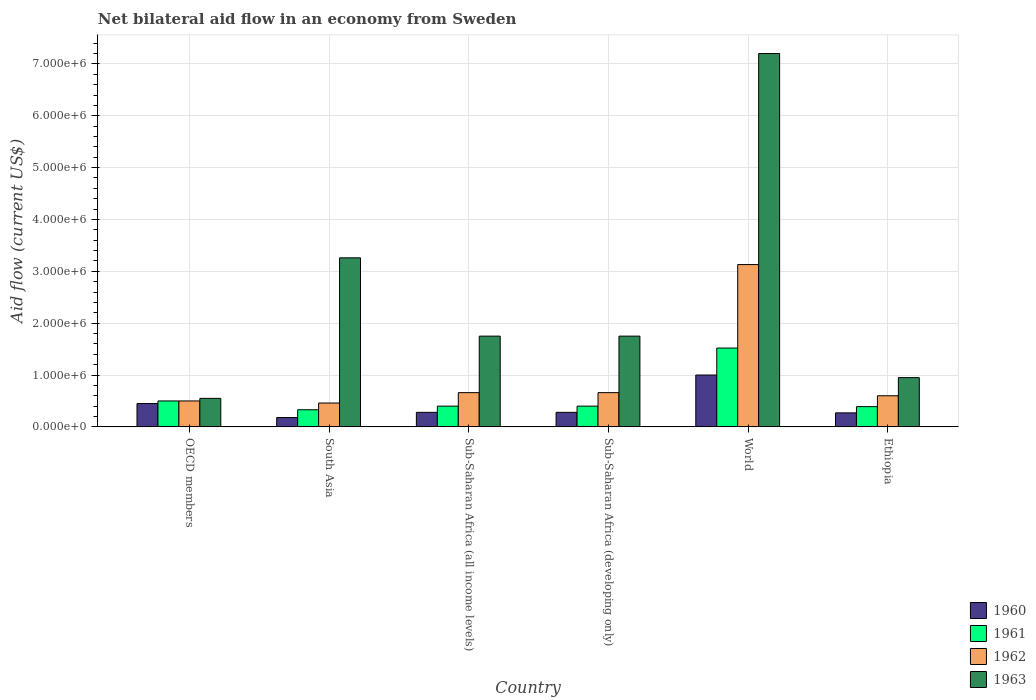How many groups of bars are there?
Offer a very short reply. 6. Are the number of bars per tick equal to the number of legend labels?
Provide a succinct answer. Yes. Are the number of bars on each tick of the X-axis equal?
Make the answer very short. Yes. What is the label of the 4th group of bars from the left?
Ensure brevity in your answer.  Sub-Saharan Africa (developing only). What is the net bilateral aid flow in 1960 in OECD members?
Provide a succinct answer. 4.50e+05. Across all countries, what is the maximum net bilateral aid flow in 1962?
Make the answer very short. 3.13e+06. Across all countries, what is the minimum net bilateral aid flow in 1960?
Offer a terse response. 1.80e+05. In which country was the net bilateral aid flow in 1963 maximum?
Your answer should be compact. World. What is the total net bilateral aid flow in 1961 in the graph?
Keep it short and to the point. 3.54e+06. What is the difference between the net bilateral aid flow in 1963 in Ethiopia and that in Sub-Saharan Africa (all income levels)?
Give a very brief answer. -8.00e+05. What is the difference between the net bilateral aid flow in 1961 in Ethiopia and the net bilateral aid flow in 1960 in World?
Offer a very short reply. -6.10e+05. What is the average net bilateral aid flow in 1962 per country?
Ensure brevity in your answer.  1.00e+06. What is the difference between the net bilateral aid flow of/in 1963 and net bilateral aid flow of/in 1961 in Ethiopia?
Your answer should be compact. 5.60e+05. What is the ratio of the net bilateral aid flow in 1962 in Sub-Saharan Africa (all income levels) to that in World?
Offer a very short reply. 0.21. Is the net bilateral aid flow in 1962 in Ethiopia less than that in Sub-Saharan Africa (all income levels)?
Your answer should be compact. Yes. Is the difference between the net bilateral aid flow in 1963 in Ethiopia and Sub-Saharan Africa (developing only) greater than the difference between the net bilateral aid flow in 1961 in Ethiopia and Sub-Saharan Africa (developing only)?
Keep it short and to the point. No. What is the difference between the highest and the second highest net bilateral aid flow in 1961?
Ensure brevity in your answer.  1.02e+06. What is the difference between the highest and the lowest net bilateral aid flow in 1963?
Give a very brief answer. 6.65e+06. What does the 2nd bar from the left in Sub-Saharan Africa (developing only) represents?
Ensure brevity in your answer.  1961. What does the 1st bar from the right in Sub-Saharan Africa (all income levels) represents?
Provide a short and direct response. 1963. Is it the case that in every country, the sum of the net bilateral aid flow in 1962 and net bilateral aid flow in 1961 is greater than the net bilateral aid flow in 1963?
Your response must be concise. No. How many bars are there?
Your answer should be compact. 24. Are all the bars in the graph horizontal?
Make the answer very short. No. What is the difference between two consecutive major ticks on the Y-axis?
Offer a very short reply. 1.00e+06. Does the graph contain any zero values?
Keep it short and to the point. No. How many legend labels are there?
Give a very brief answer. 4. How are the legend labels stacked?
Provide a short and direct response. Vertical. What is the title of the graph?
Your answer should be very brief. Net bilateral aid flow in an economy from Sweden. What is the label or title of the X-axis?
Give a very brief answer. Country. What is the Aid flow (current US$) of 1961 in OECD members?
Offer a terse response. 5.00e+05. What is the Aid flow (current US$) of 1962 in OECD members?
Your answer should be compact. 5.00e+05. What is the Aid flow (current US$) of 1963 in OECD members?
Ensure brevity in your answer.  5.50e+05. What is the Aid flow (current US$) in 1961 in South Asia?
Your answer should be very brief. 3.30e+05. What is the Aid flow (current US$) of 1962 in South Asia?
Offer a very short reply. 4.60e+05. What is the Aid flow (current US$) in 1963 in South Asia?
Your response must be concise. 3.26e+06. What is the Aid flow (current US$) of 1961 in Sub-Saharan Africa (all income levels)?
Your answer should be compact. 4.00e+05. What is the Aid flow (current US$) in 1962 in Sub-Saharan Africa (all income levels)?
Offer a terse response. 6.60e+05. What is the Aid flow (current US$) of 1963 in Sub-Saharan Africa (all income levels)?
Make the answer very short. 1.75e+06. What is the Aid flow (current US$) of 1961 in Sub-Saharan Africa (developing only)?
Provide a succinct answer. 4.00e+05. What is the Aid flow (current US$) in 1963 in Sub-Saharan Africa (developing only)?
Make the answer very short. 1.75e+06. What is the Aid flow (current US$) in 1961 in World?
Your response must be concise. 1.52e+06. What is the Aid flow (current US$) in 1962 in World?
Make the answer very short. 3.13e+06. What is the Aid flow (current US$) of 1963 in World?
Offer a terse response. 7.20e+06. What is the Aid flow (current US$) in 1960 in Ethiopia?
Keep it short and to the point. 2.70e+05. What is the Aid flow (current US$) in 1961 in Ethiopia?
Make the answer very short. 3.90e+05. What is the Aid flow (current US$) in 1963 in Ethiopia?
Ensure brevity in your answer.  9.50e+05. Across all countries, what is the maximum Aid flow (current US$) of 1960?
Your answer should be very brief. 1.00e+06. Across all countries, what is the maximum Aid flow (current US$) in 1961?
Your answer should be compact. 1.52e+06. Across all countries, what is the maximum Aid flow (current US$) of 1962?
Keep it short and to the point. 3.13e+06. Across all countries, what is the maximum Aid flow (current US$) in 1963?
Your response must be concise. 7.20e+06. Across all countries, what is the minimum Aid flow (current US$) of 1960?
Keep it short and to the point. 1.80e+05. Across all countries, what is the minimum Aid flow (current US$) in 1961?
Ensure brevity in your answer.  3.30e+05. Across all countries, what is the minimum Aid flow (current US$) in 1962?
Offer a very short reply. 4.60e+05. Across all countries, what is the minimum Aid flow (current US$) in 1963?
Your response must be concise. 5.50e+05. What is the total Aid flow (current US$) in 1960 in the graph?
Keep it short and to the point. 2.46e+06. What is the total Aid flow (current US$) in 1961 in the graph?
Give a very brief answer. 3.54e+06. What is the total Aid flow (current US$) of 1962 in the graph?
Provide a short and direct response. 6.01e+06. What is the total Aid flow (current US$) of 1963 in the graph?
Offer a terse response. 1.55e+07. What is the difference between the Aid flow (current US$) of 1962 in OECD members and that in South Asia?
Provide a succinct answer. 4.00e+04. What is the difference between the Aid flow (current US$) of 1963 in OECD members and that in South Asia?
Ensure brevity in your answer.  -2.71e+06. What is the difference between the Aid flow (current US$) of 1963 in OECD members and that in Sub-Saharan Africa (all income levels)?
Offer a terse response. -1.20e+06. What is the difference between the Aid flow (current US$) in 1960 in OECD members and that in Sub-Saharan Africa (developing only)?
Your answer should be very brief. 1.70e+05. What is the difference between the Aid flow (current US$) of 1963 in OECD members and that in Sub-Saharan Africa (developing only)?
Offer a very short reply. -1.20e+06. What is the difference between the Aid flow (current US$) in 1960 in OECD members and that in World?
Offer a terse response. -5.50e+05. What is the difference between the Aid flow (current US$) in 1961 in OECD members and that in World?
Offer a very short reply. -1.02e+06. What is the difference between the Aid flow (current US$) of 1962 in OECD members and that in World?
Offer a terse response. -2.63e+06. What is the difference between the Aid flow (current US$) of 1963 in OECD members and that in World?
Give a very brief answer. -6.65e+06. What is the difference between the Aid flow (current US$) of 1960 in OECD members and that in Ethiopia?
Ensure brevity in your answer.  1.80e+05. What is the difference between the Aid flow (current US$) of 1961 in OECD members and that in Ethiopia?
Provide a short and direct response. 1.10e+05. What is the difference between the Aid flow (current US$) in 1962 in OECD members and that in Ethiopia?
Give a very brief answer. -1.00e+05. What is the difference between the Aid flow (current US$) in 1963 in OECD members and that in Ethiopia?
Your response must be concise. -4.00e+05. What is the difference between the Aid flow (current US$) of 1960 in South Asia and that in Sub-Saharan Africa (all income levels)?
Give a very brief answer. -1.00e+05. What is the difference between the Aid flow (current US$) in 1961 in South Asia and that in Sub-Saharan Africa (all income levels)?
Offer a terse response. -7.00e+04. What is the difference between the Aid flow (current US$) in 1963 in South Asia and that in Sub-Saharan Africa (all income levels)?
Your answer should be compact. 1.51e+06. What is the difference between the Aid flow (current US$) of 1960 in South Asia and that in Sub-Saharan Africa (developing only)?
Give a very brief answer. -1.00e+05. What is the difference between the Aid flow (current US$) of 1961 in South Asia and that in Sub-Saharan Africa (developing only)?
Ensure brevity in your answer.  -7.00e+04. What is the difference between the Aid flow (current US$) in 1963 in South Asia and that in Sub-Saharan Africa (developing only)?
Ensure brevity in your answer.  1.51e+06. What is the difference between the Aid flow (current US$) of 1960 in South Asia and that in World?
Provide a succinct answer. -8.20e+05. What is the difference between the Aid flow (current US$) in 1961 in South Asia and that in World?
Make the answer very short. -1.19e+06. What is the difference between the Aid flow (current US$) of 1962 in South Asia and that in World?
Offer a very short reply. -2.67e+06. What is the difference between the Aid flow (current US$) of 1963 in South Asia and that in World?
Ensure brevity in your answer.  -3.94e+06. What is the difference between the Aid flow (current US$) of 1960 in South Asia and that in Ethiopia?
Your answer should be very brief. -9.00e+04. What is the difference between the Aid flow (current US$) in 1963 in South Asia and that in Ethiopia?
Provide a succinct answer. 2.31e+06. What is the difference between the Aid flow (current US$) in 1960 in Sub-Saharan Africa (all income levels) and that in Sub-Saharan Africa (developing only)?
Offer a terse response. 0. What is the difference between the Aid flow (current US$) in 1962 in Sub-Saharan Africa (all income levels) and that in Sub-Saharan Africa (developing only)?
Give a very brief answer. 0. What is the difference between the Aid flow (current US$) in 1960 in Sub-Saharan Africa (all income levels) and that in World?
Offer a very short reply. -7.20e+05. What is the difference between the Aid flow (current US$) in 1961 in Sub-Saharan Africa (all income levels) and that in World?
Provide a short and direct response. -1.12e+06. What is the difference between the Aid flow (current US$) of 1962 in Sub-Saharan Africa (all income levels) and that in World?
Provide a short and direct response. -2.47e+06. What is the difference between the Aid flow (current US$) in 1963 in Sub-Saharan Africa (all income levels) and that in World?
Ensure brevity in your answer.  -5.45e+06. What is the difference between the Aid flow (current US$) in 1962 in Sub-Saharan Africa (all income levels) and that in Ethiopia?
Your answer should be very brief. 6.00e+04. What is the difference between the Aid flow (current US$) in 1963 in Sub-Saharan Africa (all income levels) and that in Ethiopia?
Your answer should be very brief. 8.00e+05. What is the difference between the Aid flow (current US$) in 1960 in Sub-Saharan Africa (developing only) and that in World?
Offer a terse response. -7.20e+05. What is the difference between the Aid flow (current US$) in 1961 in Sub-Saharan Africa (developing only) and that in World?
Ensure brevity in your answer.  -1.12e+06. What is the difference between the Aid flow (current US$) of 1962 in Sub-Saharan Africa (developing only) and that in World?
Offer a very short reply. -2.47e+06. What is the difference between the Aid flow (current US$) in 1963 in Sub-Saharan Africa (developing only) and that in World?
Keep it short and to the point. -5.45e+06. What is the difference between the Aid flow (current US$) of 1962 in Sub-Saharan Africa (developing only) and that in Ethiopia?
Offer a terse response. 6.00e+04. What is the difference between the Aid flow (current US$) in 1963 in Sub-Saharan Africa (developing only) and that in Ethiopia?
Offer a very short reply. 8.00e+05. What is the difference between the Aid flow (current US$) in 1960 in World and that in Ethiopia?
Keep it short and to the point. 7.30e+05. What is the difference between the Aid flow (current US$) in 1961 in World and that in Ethiopia?
Your answer should be very brief. 1.13e+06. What is the difference between the Aid flow (current US$) in 1962 in World and that in Ethiopia?
Provide a short and direct response. 2.53e+06. What is the difference between the Aid flow (current US$) of 1963 in World and that in Ethiopia?
Ensure brevity in your answer.  6.25e+06. What is the difference between the Aid flow (current US$) in 1960 in OECD members and the Aid flow (current US$) in 1961 in South Asia?
Offer a terse response. 1.20e+05. What is the difference between the Aid flow (current US$) of 1960 in OECD members and the Aid flow (current US$) of 1962 in South Asia?
Provide a succinct answer. -10000. What is the difference between the Aid flow (current US$) of 1960 in OECD members and the Aid flow (current US$) of 1963 in South Asia?
Offer a terse response. -2.81e+06. What is the difference between the Aid flow (current US$) in 1961 in OECD members and the Aid flow (current US$) in 1963 in South Asia?
Give a very brief answer. -2.76e+06. What is the difference between the Aid flow (current US$) of 1962 in OECD members and the Aid flow (current US$) of 1963 in South Asia?
Provide a succinct answer. -2.76e+06. What is the difference between the Aid flow (current US$) of 1960 in OECD members and the Aid flow (current US$) of 1961 in Sub-Saharan Africa (all income levels)?
Offer a terse response. 5.00e+04. What is the difference between the Aid flow (current US$) of 1960 in OECD members and the Aid flow (current US$) of 1962 in Sub-Saharan Africa (all income levels)?
Give a very brief answer. -2.10e+05. What is the difference between the Aid flow (current US$) of 1960 in OECD members and the Aid flow (current US$) of 1963 in Sub-Saharan Africa (all income levels)?
Offer a very short reply. -1.30e+06. What is the difference between the Aid flow (current US$) in 1961 in OECD members and the Aid flow (current US$) in 1962 in Sub-Saharan Africa (all income levels)?
Your answer should be very brief. -1.60e+05. What is the difference between the Aid flow (current US$) in 1961 in OECD members and the Aid flow (current US$) in 1963 in Sub-Saharan Africa (all income levels)?
Give a very brief answer. -1.25e+06. What is the difference between the Aid flow (current US$) in 1962 in OECD members and the Aid flow (current US$) in 1963 in Sub-Saharan Africa (all income levels)?
Make the answer very short. -1.25e+06. What is the difference between the Aid flow (current US$) in 1960 in OECD members and the Aid flow (current US$) in 1961 in Sub-Saharan Africa (developing only)?
Ensure brevity in your answer.  5.00e+04. What is the difference between the Aid flow (current US$) in 1960 in OECD members and the Aid flow (current US$) in 1962 in Sub-Saharan Africa (developing only)?
Keep it short and to the point. -2.10e+05. What is the difference between the Aid flow (current US$) in 1960 in OECD members and the Aid flow (current US$) in 1963 in Sub-Saharan Africa (developing only)?
Your answer should be very brief. -1.30e+06. What is the difference between the Aid flow (current US$) in 1961 in OECD members and the Aid flow (current US$) in 1963 in Sub-Saharan Africa (developing only)?
Offer a very short reply. -1.25e+06. What is the difference between the Aid flow (current US$) of 1962 in OECD members and the Aid flow (current US$) of 1963 in Sub-Saharan Africa (developing only)?
Ensure brevity in your answer.  -1.25e+06. What is the difference between the Aid flow (current US$) in 1960 in OECD members and the Aid flow (current US$) in 1961 in World?
Your response must be concise. -1.07e+06. What is the difference between the Aid flow (current US$) in 1960 in OECD members and the Aid flow (current US$) in 1962 in World?
Make the answer very short. -2.68e+06. What is the difference between the Aid flow (current US$) in 1960 in OECD members and the Aid flow (current US$) in 1963 in World?
Ensure brevity in your answer.  -6.75e+06. What is the difference between the Aid flow (current US$) in 1961 in OECD members and the Aid flow (current US$) in 1962 in World?
Offer a terse response. -2.63e+06. What is the difference between the Aid flow (current US$) of 1961 in OECD members and the Aid flow (current US$) of 1963 in World?
Keep it short and to the point. -6.70e+06. What is the difference between the Aid flow (current US$) in 1962 in OECD members and the Aid flow (current US$) in 1963 in World?
Your answer should be very brief. -6.70e+06. What is the difference between the Aid flow (current US$) in 1960 in OECD members and the Aid flow (current US$) in 1961 in Ethiopia?
Your answer should be very brief. 6.00e+04. What is the difference between the Aid flow (current US$) of 1960 in OECD members and the Aid flow (current US$) of 1962 in Ethiopia?
Offer a very short reply. -1.50e+05. What is the difference between the Aid flow (current US$) of 1960 in OECD members and the Aid flow (current US$) of 1963 in Ethiopia?
Ensure brevity in your answer.  -5.00e+05. What is the difference between the Aid flow (current US$) of 1961 in OECD members and the Aid flow (current US$) of 1962 in Ethiopia?
Provide a succinct answer. -1.00e+05. What is the difference between the Aid flow (current US$) in 1961 in OECD members and the Aid flow (current US$) in 1963 in Ethiopia?
Provide a succinct answer. -4.50e+05. What is the difference between the Aid flow (current US$) in 1962 in OECD members and the Aid flow (current US$) in 1963 in Ethiopia?
Make the answer very short. -4.50e+05. What is the difference between the Aid flow (current US$) in 1960 in South Asia and the Aid flow (current US$) in 1962 in Sub-Saharan Africa (all income levels)?
Make the answer very short. -4.80e+05. What is the difference between the Aid flow (current US$) of 1960 in South Asia and the Aid flow (current US$) of 1963 in Sub-Saharan Africa (all income levels)?
Your answer should be compact. -1.57e+06. What is the difference between the Aid flow (current US$) of 1961 in South Asia and the Aid flow (current US$) of 1962 in Sub-Saharan Africa (all income levels)?
Make the answer very short. -3.30e+05. What is the difference between the Aid flow (current US$) in 1961 in South Asia and the Aid flow (current US$) in 1963 in Sub-Saharan Africa (all income levels)?
Your response must be concise. -1.42e+06. What is the difference between the Aid flow (current US$) in 1962 in South Asia and the Aid flow (current US$) in 1963 in Sub-Saharan Africa (all income levels)?
Give a very brief answer. -1.29e+06. What is the difference between the Aid flow (current US$) of 1960 in South Asia and the Aid flow (current US$) of 1962 in Sub-Saharan Africa (developing only)?
Ensure brevity in your answer.  -4.80e+05. What is the difference between the Aid flow (current US$) in 1960 in South Asia and the Aid flow (current US$) in 1963 in Sub-Saharan Africa (developing only)?
Make the answer very short. -1.57e+06. What is the difference between the Aid flow (current US$) in 1961 in South Asia and the Aid flow (current US$) in 1962 in Sub-Saharan Africa (developing only)?
Your answer should be compact. -3.30e+05. What is the difference between the Aid flow (current US$) of 1961 in South Asia and the Aid flow (current US$) of 1963 in Sub-Saharan Africa (developing only)?
Provide a short and direct response. -1.42e+06. What is the difference between the Aid flow (current US$) in 1962 in South Asia and the Aid flow (current US$) in 1963 in Sub-Saharan Africa (developing only)?
Keep it short and to the point. -1.29e+06. What is the difference between the Aid flow (current US$) of 1960 in South Asia and the Aid flow (current US$) of 1961 in World?
Your response must be concise. -1.34e+06. What is the difference between the Aid flow (current US$) of 1960 in South Asia and the Aid flow (current US$) of 1962 in World?
Provide a succinct answer. -2.95e+06. What is the difference between the Aid flow (current US$) in 1960 in South Asia and the Aid flow (current US$) in 1963 in World?
Ensure brevity in your answer.  -7.02e+06. What is the difference between the Aid flow (current US$) in 1961 in South Asia and the Aid flow (current US$) in 1962 in World?
Give a very brief answer. -2.80e+06. What is the difference between the Aid flow (current US$) of 1961 in South Asia and the Aid flow (current US$) of 1963 in World?
Your answer should be very brief. -6.87e+06. What is the difference between the Aid flow (current US$) of 1962 in South Asia and the Aid flow (current US$) of 1963 in World?
Your answer should be compact. -6.74e+06. What is the difference between the Aid flow (current US$) in 1960 in South Asia and the Aid flow (current US$) in 1962 in Ethiopia?
Ensure brevity in your answer.  -4.20e+05. What is the difference between the Aid flow (current US$) of 1960 in South Asia and the Aid flow (current US$) of 1963 in Ethiopia?
Offer a terse response. -7.70e+05. What is the difference between the Aid flow (current US$) of 1961 in South Asia and the Aid flow (current US$) of 1962 in Ethiopia?
Ensure brevity in your answer.  -2.70e+05. What is the difference between the Aid flow (current US$) in 1961 in South Asia and the Aid flow (current US$) in 1963 in Ethiopia?
Make the answer very short. -6.20e+05. What is the difference between the Aid flow (current US$) in 1962 in South Asia and the Aid flow (current US$) in 1963 in Ethiopia?
Your response must be concise. -4.90e+05. What is the difference between the Aid flow (current US$) in 1960 in Sub-Saharan Africa (all income levels) and the Aid flow (current US$) in 1962 in Sub-Saharan Africa (developing only)?
Offer a very short reply. -3.80e+05. What is the difference between the Aid flow (current US$) of 1960 in Sub-Saharan Africa (all income levels) and the Aid flow (current US$) of 1963 in Sub-Saharan Africa (developing only)?
Offer a very short reply. -1.47e+06. What is the difference between the Aid flow (current US$) of 1961 in Sub-Saharan Africa (all income levels) and the Aid flow (current US$) of 1963 in Sub-Saharan Africa (developing only)?
Your response must be concise. -1.35e+06. What is the difference between the Aid flow (current US$) in 1962 in Sub-Saharan Africa (all income levels) and the Aid flow (current US$) in 1963 in Sub-Saharan Africa (developing only)?
Ensure brevity in your answer.  -1.09e+06. What is the difference between the Aid flow (current US$) of 1960 in Sub-Saharan Africa (all income levels) and the Aid flow (current US$) of 1961 in World?
Provide a succinct answer. -1.24e+06. What is the difference between the Aid flow (current US$) of 1960 in Sub-Saharan Africa (all income levels) and the Aid flow (current US$) of 1962 in World?
Your answer should be very brief. -2.85e+06. What is the difference between the Aid flow (current US$) of 1960 in Sub-Saharan Africa (all income levels) and the Aid flow (current US$) of 1963 in World?
Your response must be concise. -6.92e+06. What is the difference between the Aid flow (current US$) in 1961 in Sub-Saharan Africa (all income levels) and the Aid flow (current US$) in 1962 in World?
Your answer should be compact. -2.73e+06. What is the difference between the Aid flow (current US$) in 1961 in Sub-Saharan Africa (all income levels) and the Aid flow (current US$) in 1963 in World?
Ensure brevity in your answer.  -6.80e+06. What is the difference between the Aid flow (current US$) in 1962 in Sub-Saharan Africa (all income levels) and the Aid flow (current US$) in 1963 in World?
Offer a very short reply. -6.54e+06. What is the difference between the Aid flow (current US$) in 1960 in Sub-Saharan Africa (all income levels) and the Aid flow (current US$) in 1961 in Ethiopia?
Provide a succinct answer. -1.10e+05. What is the difference between the Aid flow (current US$) of 1960 in Sub-Saharan Africa (all income levels) and the Aid flow (current US$) of 1962 in Ethiopia?
Give a very brief answer. -3.20e+05. What is the difference between the Aid flow (current US$) in 1960 in Sub-Saharan Africa (all income levels) and the Aid flow (current US$) in 1963 in Ethiopia?
Give a very brief answer. -6.70e+05. What is the difference between the Aid flow (current US$) in 1961 in Sub-Saharan Africa (all income levels) and the Aid flow (current US$) in 1962 in Ethiopia?
Your answer should be compact. -2.00e+05. What is the difference between the Aid flow (current US$) of 1961 in Sub-Saharan Africa (all income levels) and the Aid flow (current US$) of 1963 in Ethiopia?
Provide a short and direct response. -5.50e+05. What is the difference between the Aid flow (current US$) in 1960 in Sub-Saharan Africa (developing only) and the Aid flow (current US$) in 1961 in World?
Offer a terse response. -1.24e+06. What is the difference between the Aid flow (current US$) of 1960 in Sub-Saharan Africa (developing only) and the Aid flow (current US$) of 1962 in World?
Provide a short and direct response. -2.85e+06. What is the difference between the Aid flow (current US$) of 1960 in Sub-Saharan Africa (developing only) and the Aid flow (current US$) of 1963 in World?
Offer a terse response. -6.92e+06. What is the difference between the Aid flow (current US$) in 1961 in Sub-Saharan Africa (developing only) and the Aid flow (current US$) in 1962 in World?
Give a very brief answer. -2.73e+06. What is the difference between the Aid flow (current US$) in 1961 in Sub-Saharan Africa (developing only) and the Aid flow (current US$) in 1963 in World?
Offer a very short reply. -6.80e+06. What is the difference between the Aid flow (current US$) in 1962 in Sub-Saharan Africa (developing only) and the Aid flow (current US$) in 1963 in World?
Make the answer very short. -6.54e+06. What is the difference between the Aid flow (current US$) of 1960 in Sub-Saharan Africa (developing only) and the Aid flow (current US$) of 1962 in Ethiopia?
Your answer should be compact. -3.20e+05. What is the difference between the Aid flow (current US$) of 1960 in Sub-Saharan Africa (developing only) and the Aid flow (current US$) of 1963 in Ethiopia?
Offer a terse response. -6.70e+05. What is the difference between the Aid flow (current US$) of 1961 in Sub-Saharan Africa (developing only) and the Aid flow (current US$) of 1963 in Ethiopia?
Give a very brief answer. -5.50e+05. What is the difference between the Aid flow (current US$) of 1962 in Sub-Saharan Africa (developing only) and the Aid flow (current US$) of 1963 in Ethiopia?
Ensure brevity in your answer.  -2.90e+05. What is the difference between the Aid flow (current US$) in 1960 in World and the Aid flow (current US$) in 1962 in Ethiopia?
Offer a terse response. 4.00e+05. What is the difference between the Aid flow (current US$) in 1961 in World and the Aid flow (current US$) in 1962 in Ethiopia?
Make the answer very short. 9.20e+05. What is the difference between the Aid flow (current US$) of 1961 in World and the Aid flow (current US$) of 1963 in Ethiopia?
Offer a very short reply. 5.70e+05. What is the difference between the Aid flow (current US$) of 1962 in World and the Aid flow (current US$) of 1963 in Ethiopia?
Provide a succinct answer. 2.18e+06. What is the average Aid flow (current US$) of 1960 per country?
Your answer should be compact. 4.10e+05. What is the average Aid flow (current US$) in 1961 per country?
Offer a very short reply. 5.90e+05. What is the average Aid flow (current US$) of 1962 per country?
Make the answer very short. 1.00e+06. What is the average Aid flow (current US$) in 1963 per country?
Your answer should be very brief. 2.58e+06. What is the difference between the Aid flow (current US$) in 1960 and Aid flow (current US$) in 1961 in OECD members?
Your response must be concise. -5.00e+04. What is the difference between the Aid flow (current US$) in 1960 and Aid flow (current US$) in 1963 in OECD members?
Your answer should be very brief. -1.00e+05. What is the difference between the Aid flow (current US$) in 1960 and Aid flow (current US$) in 1962 in South Asia?
Make the answer very short. -2.80e+05. What is the difference between the Aid flow (current US$) in 1960 and Aid flow (current US$) in 1963 in South Asia?
Provide a succinct answer. -3.08e+06. What is the difference between the Aid flow (current US$) in 1961 and Aid flow (current US$) in 1963 in South Asia?
Offer a terse response. -2.93e+06. What is the difference between the Aid flow (current US$) of 1962 and Aid flow (current US$) of 1963 in South Asia?
Provide a short and direct response. -2.80e+06. What is the difference between the Aid flow (current US$) in 1960 and Aid flow (current US$) in 1961 in Sub-Saharan Africa (all income levels)?
Make the answer very short. -1.20e+05. What is the difference between the Aid flow (current US$) in 1960 and Aid flow (current US$) in 1962 in Sub-Saharan Africa (all income levels)?
Your answer should be compact. -3.80e+05. What is the difference between the Aid flow (current US$) in 1960 and Aid flow (current US$) in 1963 in Sub-Saharan Africa (all income levels)?
Provide a succinct answer. -1.47e+06. What is the difference between the Aid flow (current US$) in 1961 and Aid flow (current US$) in 1963 in Sub-Saharan Africa (all income levels)?
Your answer should be very brief. -1.35e+06. What is the difference between the Aid flow (current US$) in 1962 and Aid flow (current US$) in 1963 in Sub-Saharan Africa (all income levels)?
Provide a short and direct response. -1.09e+06. What is the difference between the Aid flow (current US$) in 1960 and Aid flow (current US$) in 1961 in Sub-Saharan Africa (developing only)?
Make the answer very short. -1.20e+05. What is the difference between the Aid flow (current US$) in 1960 and Aid flow (current US$) in 1962 in Sub-Saharan Africa (developing only)?
Offer a terse response. -3.80e+05. What is the difference between the Aid flow (current US$) in 1960 and Aid flow (current US$) in 1963 in Sub-Saharan Africa (developing only)?
Offer a very short reply. -1.47e+06. What is the difference between the Aid flow (current US$) of 1961 and Aid flow (current US$) of 1962 in Sub-Saharan Africa (developing only)?
Provide a short and direct response. -2.60e+05. What is the difference between the Aid flow (current US$) of 1961 and Aid flow (current US$) of 1963 in Sub-Saharan Africa (developing only)?
Keep it short and to the point. -1.35e+06. What is the difference between the Aid flow (current US$) of 1962 and Aid flow (current US$) of 1963 in Sub-Saharan Africa (developing only)?
Ensure brevity in your answer.  -1.09e+06. What is the difference between the Aid flow (current US$) of 1960 and Aid flow (current US$) of 1961 in World?
Ensure brevity in your answer.  -5.20e+05. What is the difference between the Aid flow (current US$) of 1960 and Aid flow (current US$) of 1962 in World?
Offer a terse response. -2.13e+06. What is the difference between the Aid flow (current US$) of 1960 and Aid flow (current US$) of 1963 in World?
Your answer should be compact. -6.20e+06. What is the difference between the Aid flow (current US$) in 1961 and Aid flow (current US$) in 1962 in World?
Ensure brevity in your answer.  -1.61e+06. What is the difference between the Aid flow (current US$) of 1961 and Aid flow (current US$) of 1963 in World?
Keep it short and to the point. -5.68e+06. What is the difference between the Aid flow (current US$) of 1962 and Aid flow (current US$) of 1963 in World?
Your answer should be very brief. -4.07e+06. What is the difference between the Aid flow (current US$) of 1960 and Aid flow (current US$) of 1961 in Ethiopia?
Keep it short and to the point. -1.20e+05. What is the difference between the Aid flow (current US$) of 1960 and Aid flow (current US$) of 1962 in Ethiopia?
Provide a short and direct response. -3.30e+05. What is the difference between the Aid flow (current US$) in 1960 and Aid flow (current US$) in 1963 in Ethiopia?
Your answer should be very brief. -6.80e+05. What is the difference between the Aid flow (current US$) in 1961 and Aid flow (current US$) in 1962 in Ethiopia?
Your response must be concise. -2.10e+05. What is the difference between the Aid flow (current US$) of 1961 and Aid flow (current US$) of 1963 in Ethiopia?
Your answer should be very brief. -5.60e+05. What is the difference between the Aid flow (current US$) of 1962 and Aid flow (current US$) of 1963 in Ethiopia?
Your response must be concise. -3.50e+05. What is the ratio of the Aid flow (current US$) of 1960 in OECD members to that in South Asia?
Your answer should be very brief. 2.5. What is the ratio of the Aid flow (current US$) in 1961 in OECD members to that in South Asia?
Make the answer very short. 1.52. What is the ratio of the Aid flow (current US$) in 1962 in OECD members to that in South Asia?
Make the answer very short. 1.09. What is the ratio of the Aid flow (current US$) in 1963 in OECD members to that in South Asia?
Offer a terse response. 0.17. What is the ratio of the Aid flow (current US$) of 1960 in OECD members to that in Sub-Saharan Africa (all income levels)?
Provide a short and direct response. 1.61. What is the ratio of the Aid flow (current US$) of 1961 in OECD members to that in Sub-Saharan Africa (all income levels)?
Provide a short and direct response. 1.25. What is the ratio of the Aid flow (current US$) of 1962 in OECD members to that in Sub-Saharan Africa (all income levels)?
Offer a terse response. 0.76. What is the ratio of the Aid flow (current US$) in 1963 in OECD members to that in Sub-Saharan Africa (all income levels)?
Give a very brief answer. 0.31. What is the ratio of the Aid flow (current US$) of 1960 in OECD members to that in Sub-Saharan Africa (developing only)?
Ensure brevity in your answer.  1.61. What is the ratio of the Aid flow (current US$) of 1961 in OECD members to that in Sub-Saharan Africa (developing only)?
Make the answer very short. 1.25. What is the ratio of the Aid flow (current US$) of 1962 in OECD members to that in Sub-Saharan Africa (developing only)?
Make the answer very short. 0.76. What is the ratio of the Aid flow (current US$) in 1963 in OECD members to that in Sub-Saharan Africa (developing only)?
Your response must be concise. 0.31. What is the ratio of the Aid flow (current US$) of 1960 in OECD members to that in World?
Offer a very short reply. 0.45. What is the ratio of the Aid flow (current US$) in 1961 in OECD members to that in World?
Your answer should be very brief. 0.33. What is the ratio of the Aid flow (current US$) of 1962 in OECD members to that in World?
Give a very brief answer. 0.16. What is the ratio of the Aid flow (current US$) in 1963 in OECD members to that in World?
Provide a succinct answer. 0.08. What is the ratio of the Aid flow (current US$) of 1961 in OECD members to that in Ethiopia?
Provide a succinct answer. 1.28. What is the ratio of the Aid flow (current US$) of 1963 in OECD members to that in Ethiopia?
Provide a succinct answer. 0.58. What is the ratio of the Aid flow (current US$) of 1960 in South Asia to that in Sub-Saharan Africa (all income levels)?
Your answer should be compact. 0.64. What is the ratio of the Aid flow (current US$) in 1961 in South Asia to that in Sub-Saharan Africa (all income levels)?
Your answer should be compact. 0.82. What is the ratio of the Aid flow (current US$) of 1962 in South Asia to that in Sub-Saharan Africa (all income levels)?
Provide a short and direct response. 0.7. What is the ratio of the Aid flow (current US$) in 1963 in South Asia to that in Sub-Saharan Africa (all income levels)?
Offer a terse response. 1.86. What is the ratio of the Aid flow (current US$) in 1960 in South Asia to that in Sub-Saharan Africa (developing only)?
Give a very brief answer. 0.64. What is the ratio of the Aid flow (current US$) in 1961 in South Asia to that in Sub-Saharan Africa (developing only)?
Provide a succinct answer. 0.82. What is the ratio of the Aid flow (current US$) of 1962 in South Asia to that in Sub-Saharan Africa (developing only)?
Provide a short and direct response. 0.7. What is the ratio of the Aid flow (current US$) in 1963 in South Asia to that in Sub-Saharan Africa (developing only)?
Your answer should be very brief. 1.86. What is the ratio of the Aid flow (current US$) in 1960 in South Asia to that in World?
Provide a succinct answer. 0.18. What is the ratio of the Aid flow (current US$) in 1961 in South Asia to that in World?
Your answer should be very brief. 0.22. What is the ratio of the Aid flow (current US$) of 1962 in South Asia to that in World?
Provide a short and direct response. 0.15. What is the ratio of the Aid flow (current US$) in 1963 in South Asia to that in World?
Offer a very short reply. 0.45. What is the ratio of the Aid flow (current US$) of 1961 in South Asia to that in Ethiopia?
Your answer should be compact. 0.85. What is the ratio of the Aid flow (current US$) of 1962 in South Asia to that in Ethiopia?
Your answer should be very brief. 0.77. What is the ratio of the Aid flow (current US$) in 1963 in South Asia to that in Ethiopia?
Give a very brief answer. 3.43. What is the ratio of the Aid flow (current US$) of 1960 in Sub-Saharan Africa (all income levels) to that in Sub-Saharan Africa (developing only)?
Your response must be concise. 1. What is the ratio of the Aid flow (current US$) of 1961 in Sub-Saharan Africa (all income levels) to that in Sub-Saharan Africa (developing only)?
Provide a short and direct response. 1. What is the ratio of the Aid flow (current US$) of 1963 in Sub-Saharan Africa (all income levels) to that in Sub-Saharan Africa (developing only)?
Ensure brevity in your answer.  1. What is the ratio of the Aid flow (current US$) in 1960 in Sub-Saharan Africa (all income levels) to that in World?
Offer a very short reply. 0.28. What is the ratio of the Aid flow (current US$) in 1961 in Sub-Saharan Africa (all income levels) to that in World?
Give a very brief answer. 0.26. What is the ratio of the Aid flow (current US$) of 1962 in Sub-Saharan Africa (all income levels) to that in World?
Your answer should be compact. 0.21. What is the ratio of the Aid flow (current US$) of 1963 in Sub-Saharan Africa (all income levels) to that in World?
Your answer should be compact. 0.24. What is the ratio of the Aid flow (current US$) in 1961 in Sub-Saharan Africa (all income levels) to that in Ethiopia?
Give a very brief answer. 1.03. What is the ratio of the Aid flow (current US$) of 1962 in Sub-Saharan Africa (all income levels) to that in Ethiopia?
Offer a very short reply. 1.1. What is the ratio of the Aid flow (current US$) of 1963 in Sub-Saharan Africa (all income levels) to that in Ethiopia?
Give a very brief answer. 1.84. What is the ratio of the Aid flow (current US$) in 1960 in Sub-Saharan Africa (developing only) to that in World?
Your response must be concise. 0.28. What is the ratio of the Aid flow (current US$) of 1961 in Sub-Saharan Africa (developing only) to that in World?
Provide a short and direct response. 0.26. What is the ratio of the Aid flow (current US$) of 1962 in Sub-Saharan Africa (developing only) to that in World?
Keep it short and to the point. 0.21. What is the ratio of the Aid flow (current US$) in 1963 in Sub-Saharan Africa (developing only) to that in World?
Your answer should be very brief. 0.24. What is the ratio of the Aid flow (current US$) of 1960 in Sub-Saharan Africa (developing only) to that in Ethiopia?
Offer a very short reply. 1.04. What is the ratio of the Aid flow (current US$) of 1961 in Sub-Saharan Africa (developing only) to that in Ethiopia?
Provide a short and direct response. 1.03. What is the ratio of the Aid flow (current US$) of 1963 in Sub-Saharan Africa (developing only) to that in Ethiopia?
Provide a short and direct response. 1.84. What is the ratio of the Aid flow (current US$) of 1960 in World to that in Ethiopia?
Ensure brevity in your answer.  3.7. What is the ratio of the Aid flow (current US$) of 1961 in World to that in Ethiopia?
Your answer should be very brief. 3.9. What is the ratio of the Aid flow (current US$) in 1962 in World to that in Ethiopia?
Your answer should be compact. 5.22. What is the ratio of the Aid flow (current US$) of 1963 in World to that in Ethiopia?
Make the answer very short. 7.58. What is the difference between the highest and the second highest Aid flow (current US$) in 1960?
Offer a terse response. 5.50e+05. What is the difference between the highest and the second highest Aid flow (current US$) of 1961?
Give a very brief answer. 1.02e+06. What is the difference between the highest and the second highest Aid flow (current US$) in 1962?
Give a very brief answer. 2.47e+06. What is the difference between the highest and the second highest Aid flow (current US$) of 1963?
Your answer should be compact. 3.94e+06. What is the difference between the highest and the lowest Aid flow (current US$) in 1960?
Provide a short and direct response. 8.20e+05. What is the difference between the highest and the lowest Aid flow (current US$) in 1961?
Make the answer very short. 1.19e+06. What is the difference between the highest and the lowest Aid flow (current US$) in 1962?
Provide a short and direct response. 2.67e+06. What is the difference between the highest and the lowest Aid flow (current US$) in 1963?
Provide a succinct answer. 6.65e+06. 